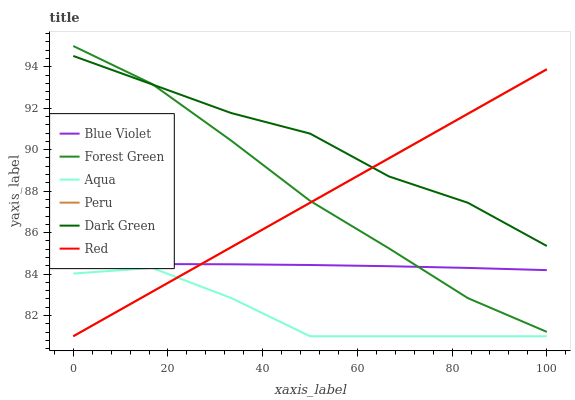Does Forest Green have the minimum area under the curve?
Answer yes or no. No. Does Forest Green have the maximum area under the curve?
Answer yes or no. No. Is Forest Green the smoothest?
Answer yes or no. No. Is Forest Green the roughest?
Answer yes or no. No. Does Forest Green have the lowest value?
Answer yes or no. No. Does Blue Violet have the highest value?
Answer yes or no. No. Is Aqua less than Dark Green?
Answer yes or no. Yes. Is Forest Green greater than Aqua?
Answer yes or no. Yes. Does Aqua intersect Dark Green?
Answer yes or no. No. 